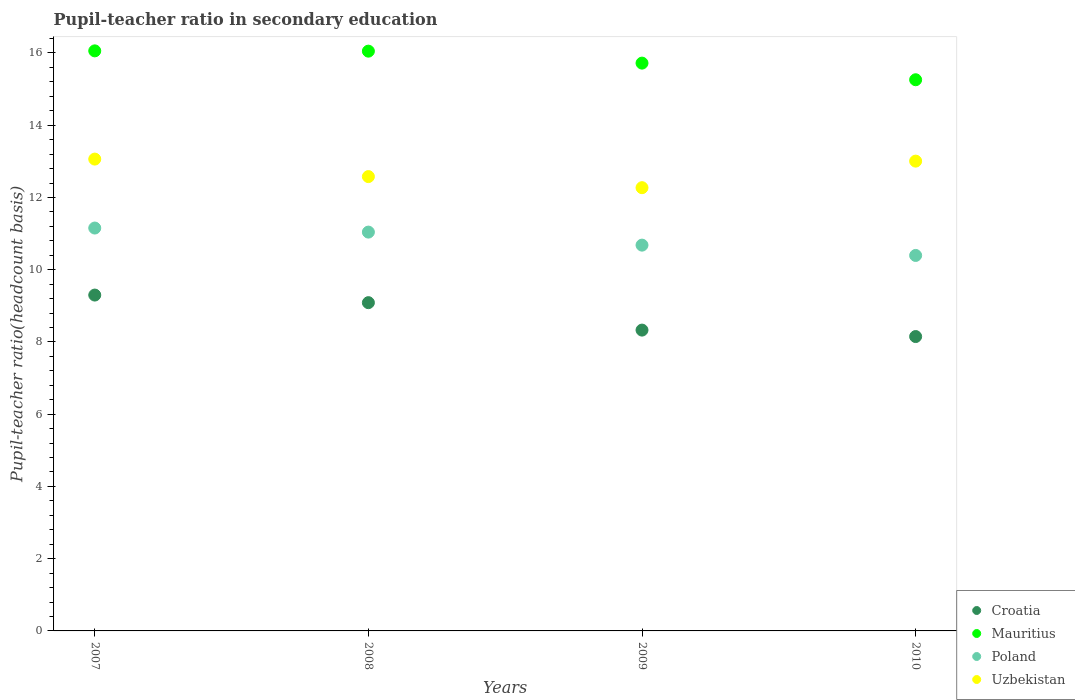How many different coloured dotlines are there?
Offer a very short reply. 4. What is the pupil-teacher ratio in secondary education in Uzbekistan in 2009?
Your answer should be compact. 12.27. Across all years, what is the maximum pupil-teacher ratio in secondary education in Poland?
Your response must be concise. 11.15. Across all years, what is the minimum pupil-teacher ratio in secondary education in Poland?
Provide a short and direct response. 10.39. In which year was the pupil-teacher ratio in secondary education in Mauritius minimum?
Offer a terse response. 2010. What is the total pupil-teacher ratio in secondary education in Poland in the graph?
Provide a succinct answer. 43.27. What is the difference between the pupil-teacher ratio in secondary education in Uzbekistan in 2008 and that in 2010?
Your answer should be very brief. -0.43. What is the difference between the pupil-teacher ratio in secondary education in Mauritius in 2009 and the pupil-teacher ratio in secondary education in Croatia in 2008?
Keep it short and to the point. 6.63. What is the average pupil-teacher ratio in secondary education in Uzbekistan per year?
Offer a terse response. 12.73. In the year 2009, what is the difference between the pupil-teacher ratio in secondary education in Croatia and pupil-teacher ratio in secondary education in Mauritius?
Keep it short and to the point. -7.39. What is the ratio of the pupil-teacher ratio in secondary education in Uzbekistan in 2007 to that in 2010?
Offer a very short reply. 1. Is the difference between the pupil-teacher ratio in secondary education in Croatia in 2007 and 2008 greater than the difference between the pupil-teacher ratio in secondary education in Mauritius in 2007 and 2008?
Ensure brevity in your answer.  Yes. What is the difference between the highest and the second highest pupil-teacher ratio in secondary education in Croatia?
Provide a short and direct response. 0.21. What is the difference between the highest and the lowest pupil-teacher ratio in secondary education in Uzbekistan?
Provide a succinct answer. 0.79. In how many years, is the pupil-teacher ratio in secondary education in Uzbekistan greater than the average pupil-teacher ratio in secondary education in Uzbekistan taken over all years?
Offer a very short reply. 2. Is it the case that in every year, the sum of the pupil-teacher ratio in secondary education in Croatia and pupil-teacher ratio in secondary education in Uzbekistan  is greater than the sum of pupil-teacher ratio in secondary education in Mauritius and pupil-teacher ratio in secondary education in Poland?
Provide a succinct answer. No. Is the pupil-teacher ratio in secondary education in Mauritius strictly less than the pupil-teacher ratio in secondary education in Uzbekistan over the years?
Make the answer very short. No. How many dotlines are there?
Give a very brief answer. 4. How many years are there in the graph?
Make the answer very short. 4. What is the difference between two consecutive major ticks on the Y-axis?
Your response must be concise. 2. Are the values on the major ticks of Y-axis written in scientific E-notation?
Make the answer very short. No. Does the graph contain any zero values?
Your answer should be compact. No. Does the graph contain grids?
Your answer should be very brief. No. How many legend labels are there?
Make the answer very short. 4. What is the title of the graph?
Make the answer very short. Pupil-teacher ratio in secondary education. What is the label or title of the Y-axis?
Make the answer very short. Pupil-teacher ratio(headcount basis). What is the Pupil-teacher ratio(headcount basis) in Croatia in 2007?
Provide a short and direct response. 9.3. What is the Pupil-teacher ratio(headcount basis) of Mauritius in 2007?
Give a very brief answer. 16.06. What is the Pupil-teacher ratio(headcount basis) in Poland in 2007?
Offer a very short reply. 11.15. What is the Pupil-teacher ratio(headcount basis) in Uzbekistan in 2007?
Your answer should be very brief. 13.06. What is the Pupil-teacher ratio(headcount basis) in Croatia in 2008?
Your response must be concise. 9.09. What is the Pupil-teacher ratio(headcount basis) in Mauritius in 2008?
Provide a short and direct response. 16.05. What is the Pupil-teacher ratio(headcount basis) of Poland in 2008?
Your answer should be very brief. 11.04. What is the Pupil-teacher ratio(headcount basis) of Uzbekistan in 2008?
Ensure brevity in your answer.  12.58. What is the Pupil-teacher ratio(headcount basis) of Croatia in 2009?
Your answer should be very brief. 8.33. What is the Pupil-teacher ratio(headcount basis) in Mauritius in 2009?
Offer a terse response. 15.72. What is the Pupil-teacher ratio(headcount basis) in Poland in 2009?
Offer a terse response. 10.68. What is the Pupil-teacher ratio(headcount basis) of Uzbekistan in 2009?
Your answer should be very brief. 12.27. What is the Pupil-teacher ratio(headcount basis) of Croatia in 2010?
Offer a very short reply. 8.15. What is the Pupil-teacher ratio(headcount basis) in Mauritius in 2010?
Provide a short and direct response. 15.26. What is the Pupil-teacher ratio(headcount basis) of Poland in 2010?
Provide a succinct answer. 10.39. What is the Pupil-teacher ratio(headcount basis) of Uzbekistan in 2010?
Offer a very short reply. 13.01. Across all years, what is the maximum Pupil-teacher ratio(headcount basis) in Croatia?
Give a very brief answer. 9.3. Across all years, what is the maximum Pupil-teacher ratio(headcount basis) of Mauritius?
Your answer should be compact. 16.06. Across all years, what is the maximum Pupil-teacher ratio(headcount basis) of Poland?
Give a very brief answer. 11.15. Across all years, what is the maximum Pupil-teacher ratio(headcount basis) in Uzbekistan?
Ensure brevity in your answer.  13.06. Across all years, what is the minimum Pupil-teacher ratio(headcount basis) in Croatia?
Your answer should be very brief. 8.15. Across all years, what is the minimum Pupil-teacher ratio(headcount basis) of Mauritius?
Give a very brief answer. 15.26. Across all years, what is the minimum Pupil-teacher ratio(headcount basis) in Poland?
Provide a succinct answer. 10.39. Across all years, what is the minimum Pupil-teacher ratio(headcount basis) in Uzbekistan?
Provide a succinct answer. 12.27. What is the total Pupil-teacher ratio(headcount basis) of Croatia in the graph?
Your response must be concise. 34.86. What is the total Pupil-teacher ratio(headcount basis) of Mauritius in the graph?
Offer a terse response. 63.09. What is the total Pupil-teacher ratio(headcount basis) in Poland in the graph?
Give a very brief answer. 43.27. What is the total Pupil-teacher ratio(headcount basis) in Uzbekistan in the graph?
Your answer should be compact. 50.92. What is the difference between the Pupil-teacher ratio(headcount basis) in Croatia in 2007 and that in 2008?
Make the answer very short. 0.21. What is the difference between the Pupil-teacher ratio(headcount basis) in Mauritius in 2007 and that in 2008?
Your response must be concise. 0.01. What is the difference between the Pupil-teacher ratio(headcount basis) in Poland in 2007 and that in 2008?
Provide a short and direct response. 0.11. What is the difference between the Pupil-teacher ratio(headcount basis) of Uzbekistan in 2007 and that in 2008?
Provide a short and direct response. 0.48. What is the difference between the Pupil-teacher ratio(headcount basis) of Croatia in 2007 and that in 2009?
Provide a succinct answer. 0.97. What is the difference between the Pupil-teacher ratio(headcount basis) of Mauritius in 2007 and that in 2009?
Give a very brief answer. 0.34. What is the difference between the Pupil-teacher ratio(headcount basis) in Poland in 2007 and that in 2009?
Provide a succinct answer. 0.47. What is the difference between the Pupil-teacher ratio(headcount basis) in Uzbekistan in 2007 and that in 2009?
Give a very brief answer. 0.79. What is the difference between the Pupil-teacher ratio(headcount basis) in Croatia in 2007 and that in 2010?
Ensure brevity in your answer.  1.15. What is the difference between the Pupil-teacher ratio(headcount basis) in Mauritius in 2007 and that in 2010?
Keep it short and to the point. 0.8. What is the difference between the Pupil-teacher ratio(headcount basis) of Poland in 2007 and that in 2010?
Provide a succinct answer. 0.76. What is the difference between the Pupil-teacher ratio(headcount basis) of Uzbekistan in 2007 and that in 2010?
Your response must be concise. 0.06. What is the difference between the Pupil-teacher ratio(headcount basis) of Croatia in 2008 and that in 2009?
Provide a succinct answer. 0.76. What is the difference between the Pupil-teacher ratio(headcount basis) in Mauritius in 2008 and that in 2009?
Offer a very short reply. 0.33. What is the difference between the Pupil-teacher ratio(headcount basis) of Poland in 2008 and that in 2009?
Provide a succinct answer. 0.36. What is the difference between the Pupil-teacher ratio(headcount basis) of Uzbekistan in 2008 and that in 2009?
Ensure brevity in your answer.  0.31. What is the difference between the Pupil-teacher ratio(headcount basis) of Croatia in 2008 and that in 2010?
Your response must be concise. 0.94. What is the difference between the Pupil-teacher ratio(headcount basis) in Mauritius in 2008 and that in 2010?
Your answer should be very brief. 0.79. What is the difference between the Pupil-teacher ratio(headcount basis) in Poland in 2008 and that in 2010?
Provide a short and direct response. 0.65. What is the difference between the Pupil-teacher ratio(headcount basis) in Uzbekistan in 2008 and that in 2010?
Offer a terse response. -0.43. What is the difference between the Pupil-teacher ratio(headcount basis) of Croatia in 2009 and that in 2010?
Your answer should be compact. 0.18. What is the difference between the Pupil-teacher ratio(headcount basis) of Mauritius in 2009 and that in 2010?
Provide a short and direct response. 0.46. What is the difference between the Pupil-teacher ratio(headcount basis) of Poland in 2009 and that in 2010?
Make the answer very short. 0.29. What is the difference between the Pupil-teacher ratio(headcount basis) of Uzbekistan in 2009 and that in 2010?
Provide a short and direct response. -0.74. What is the difference between the Pupil-teacher ratio(headcount basis) in Croatia in 2007 and the Pupil-teacher ratio(headcount basis) in Mauritius in 2008?
Your answer should be compact. -6.75. What is the difference between the Pupil-teacher ratio(headcount basis) of Croatia in 2007 and the Pupil-teacher ratio(headcount basis) of Poland in 2008?
Offer a terse response. -1.74. What is the difference between the Pupil-teacher ratio(headcount basis) in Croatia in 2007 and the Pupil-teacher ratio(headcount basis) in Uzbekistan in 2008?
Provide a succinct answer. -3.28. What is the difference between the Pupil-teacher ratio(headcount basis) in Mauritius in 2007 and the Pupil-teacher ratio(headcount basis) in Poland in 2008?
Your answer should be compact. 5.02. What is the difference between the Pupil-teacher ratio(headcount basis) of Mauritius in 2007 and the Pupil-teacher ratio(headcount basis) of Uzbekistan in 2008?
Ensure brevity in your answer.  3.48. What is the difference between the Pupil-teacher ratio(headcount basis) in Poland in 2007 and the Pupil-teacher ratio(headcount basis) in Uzbekistan in 2008?
Your answer should be very brief. -1.42. What is the difference between the Pupil-teacher ratio(headcount basis) in Croatia in 2007 and the Pupil-teacher ratio(headcount basis) in Mauritius in 2009?
Your response must be concise. -6.42. What is the difference between the Pupil-teacher ratio(headcount basis) in Croatia in 2007 and the Pupil-teacher ratio(headcount basis) in Poland in 2009?
Your answer should be compact. -1.38. What is the difference between the Pupil-teacher ratio(headcount basis) in Croatia in 2007 and the Pupil-teacher ratio(headcount basis) in Uzbekistan in 2009?
Your response must be concise. -2.97. What is the difference between the Pupil-teacher ratio(headcount basis) of Mauritius in 2007 and the Pupil-teacher ratio(headcount basis) of Poland in 2009?
Make the answer very short. 5.38. What is the difference between the Pupil-teacher ratio(headcount basis) in Mauritius in 2007 and the Pupil-teacher ratio(headcount basis) in Uzbekistan in 2009?
Your answer should be compact. 3.79. What is the difference between the Pupil-teacher ratio(headcount basis) in Poland in 2007 and the Pupil-teacher ratio(headcount basis) in Uzbekistan in 2009?
Give a very brief answer. -1.12. What is the difference between the Pupil-teacher ratio(headcount basis) of Croatia in 2007 and the Pupil-teacher ratio(headcount basis) of Mauritius in 2010?
Ensure brevity in your answer.  -5.96. What is the difference between the Pupil-teacher ratio(headcount basis) of Croatia in 2007 and the Pupil-teacher ratio(headcount basis) of Poland in 2010?
Ensure brevity in your answer.  -1.1. What is the difference between the Pupil-teacher ratio(headcount basis) of Croatia in 2007 and the Pupil-teacher ratio(headcount basis) of Uzbekistan in 2010?
Give a very brief answer. -3.71. What is the difference between the Pupil-teacher ratio(headcount basis) in Mauritius in 2007 and the Pupil-teacher ratio(headcount basis) in Poland in 2010?
Your answer should be very brief. 5.66. What is the difference between the Pupil-teacher ratio(headcount basis) of Mauritius in 2007 and the Pupil-teacher ratio(headcount basis) of Uzbekistan in 2010?
Keep it short and to the point. 3.05. What is the difference between the Pupil-teacher ratio(headcount basis) of Poland in 2007 and the Pupil-teacher ratio(headcount basis) of Uzbekistan in 2010?
Your answer should be compact. -1.85. What is the difference between the Pupil-teacher ratio(headcount basis) of Croatia in 2008 and the Pupil-teacher ratio(headcount basis) of Mauritius in 2009?
Make the answer very short. -6.63. What is the difference between the Pupil-teacher ratio(headcount basis) of Croatia in 2008 and the Pupil-teacher ratio(headcount basis) of Poland in 2009?
Provide a succinct answer. -1.59. What is the difference between the Pupil-teacher ratio(headcount basis) of Croatia in 2008 and the Pupil-teacher ratio(headcount basis) of Uzbekistan in 2009?
Your response must be concise. -3.18. What is the difference between the Pupil-teacher ratio(headcount basis) in Mauritius in 2008 and the Pupil-teacher ratio(headcount basis) in Poland in 2009?
Offer a terse response. 5.37. What is the difference between the Pupil-teacher ratio(headcount basis) in Mauritius in 2008 and the Pupil-teacher ratio(headcount basis) in Uzbekistan in 2009?
Ensure brevity in your answer.  3.78. What is the difference between the Pupil-teacher ratio(headcount basis) of Poland in 2008 and the Pupil-teacher ratio(headcount basis) of Uzbekistan in 2009?
Ensure brevity in your answer.  -1.23. What is the difference between the Pupil-teacher ratio(headcount basis) in Croatia in 2008 and the Pupil-teacher ratio(headcount basis) in Mauritius in 2010?
Provide a short and direct response. -6.17. What is the difference between the Pupil-teacher ratio(headcount basis) in Croatia in 2008 and the Pupil-teacher ratio(headcount basis) in Poland in 2010?
Give a very brief answer. -1.31. What is the difference between the Pupil-teacher ratio(headcount basis) in Croatia in 2008 and the Pupil-teacher ratio(headcount basis) in Uzbekistan in 2010?
Provide a short and direct response. -3.92. What is the difference between the Pupil-teacher ratio(headcount basis) in Mauritius in 2008 and the Pupil-teacher ratio(headcount basis) in Poland in 2010?
Keep it short and to the point. 5.66. What is the difference between the Pupil-teacher ratio(headcount basis) in Mauritius in 2008 and the Pupil-teacher ratio(headcount basis) in Uzbekistan in 2010?
Ensure brevity in your answer.  3.04. What is the difference between the Pupil-teacher ratio(headcount basis) in Poland in 2008 and the Pupil-teacher ratio(headcount basis) in Uzbekistan in 2010?
Provide a short and direct response. -1.97. What is the difference between the Pupil-teacher ratio(headcount basis) of Croatia in 2009 and the Pupil-teacher ratio(headcount basis) of Mauritius in 2010?
Ensure brevity in your answer.  -6.93. What is the difference between the Pupil-teacher ratio(headcount basis) of Croatia in 2009 and the Pupil-teacher ratio(headcount basis) of Poland in 2010?
Your answer should be very brief. -2.07. What is the difference between the Pupil-teacher ratio(headcount basis) in Croatia in 2009 and the Pupil-teacher ratio(headcount basis) in Uzbekistan in 2010?
Provide a short and direct response. -4.68. What is the difference between the Pupil-teacher ratio(headcount basis) of Mauritius in 2009 and the Pupil-teacher ratio(headcount basis) of Poland in 2010?
Ensure brevity in your answer.  5.32. What is the difference between the Pupil-teacher ratio(headcount basis) of Mauritius in 2009 and the Pupil-teacher ratio(headcount basis) of Uzbekistan in 2010?
Keep it short and to the point. 2.71. What is the difference between the Pupil-teacher ratio(headcount basis) of Poland in 2009 and the Pupil-teacher ratio(headcount basis) of Uzbekistan in 2010?
Provide a short and direct response. -2.33. What is the average Pupil-teacher ratio(headcount basis) in Croatia per year?
Your answer should be very brief. 8.72. What is the average Pupil-teacher ratio(headcount basis) in Mauritius per year?
Offer a very short reply. 15.77. What is the average Pupil-teacher ratio(headcount basis) of Poland per year?
Your answer should be compact. 10.82. What is the average Pupil-teacher ratio(headcount basis) in Uzbekistan per year?
Provide a short and direct response. 12.73. In the year 2007, what is the difference between the Pupil-teacher ratio(headcount basis) in Croatia and Pupil-teacher ratio(headcount basis) in Mauritius?
Make the answer very short. -6.76. In the year 2007, what is the difference between the Pupil-teacher ratio(headcount basis) in Croatia and Pupil-teacher ratio(headcount basis) in Poland?
Your response must be concise. -1.86. In the year 2007, what is the difference between the Pupil-teacher ratio(headcount basis) in Croatia and Pupil-teacher ratio(headcount basis) in Uzbekistan?
Provide a succinct answer. -3.76. In the year 2007, what is the difference between the Pupil-teacher ratio(headcount basis) in Mauritius and Pupil-teacher ratio(headcount basis) in Poland?
Your answer should be very brief. 4.91. In the year 2007, what is the difference between the Pupil-teacher ratio(headcount basis) of Mauritius and Pupil-teacher ratio(headcount basis) of Uzbekistan?
Ensure brevity in your answer.  3. In the year 2007, what is the difference between the Pupil-teacher ratio(headcount basis) of Poland and Pupil-teacher ratio(headcount basis) of Uzbekistan?
Provide a short and direct response. -1.91. In the year 2008, what is the difference between the Pupil-teacher ratio(headcount basis) in Croatia and Pupil-teacher ratio(headcount basis) in Mauritius?
Offer a very short reply. -6.96. In the year 2008, what is the difference between the Pupil-teacher ratio(headcount basis) of Croatia and Pupil-teacher ratio(headcount basis) of Poland?
Ensure brevity in your answer.  -1.95. In the year 2008, what is the difference between the Pupil-teacher ratio(headcount basis) in Croatia and Pupil-teacher ratio(headcount basis) in Uzbekistan?
Make the answer very short. -3.49. In the year 2008, what is the difference between the Pupil-teacher ratio(headcount basis) of Mauritius and Pupil-teacher ratio(headcount basis) of Poland?
Offer a terse response. 5.01. In the year 2008, what is the difference between the Pupil-teacher ratio(headcount basis) of Mauritius and Pupil-teacher ratio(headcount basis) of Uzbekistan?
Provide a short and direct response. 3.47. In the year 2008, what is the difference between the Pupil-teacher ratio(headcount basis) of Poland and Pupil-teacher ratio(headcount basis) of Uzbekistan?
Provide a short and direct response. -1.54. In the year 2009, what is the difference between the Pupil-teacher ratio(headcount basis) of Croatia and Pupil-teacher ratio(headcount basis) of Mauritius?
Offer a very short reply. -7.39. In the year 2009, what is the difference between the Pupil-teacher ratio(headcount basis) of Croatia and Pupil-teacher ratio(headcount basis) of Poland?
Keep it short and to the point. -2.35. In the year 2009, what is the difference between the Pupil-teacher ratio(headcount basis) of Croatia and Pupil-teacher ratio(headcount basis) of Uzbekistan?
Offer a terse response. -3.94. In the year 2009, what is the difference between the Pupil-teacher ratio(headcount basis) of Mauritius and Pupil-teacher ratio(headcount basis) of Poland?
Provide a short and direct response. 5.04. In the year 2009, what is the difference between the Pupil-teacher ratio(headcount basis) of Mauritius and Pupil-teacher ratio(headcount basis) of Uzbekistan?
Make the answer very short. 3.45. In the year 2009, what is the difference between the Pupil-teacher ratio(headcount basis) of Poland and Pupil-teacher ratio(headcount basis) of Uzbekistan?
Keep it short and to the point. -1.59. In the year 2010, what is the difference between the Pupil-teacher ratio(headcount basis) of Croatia and Pupil-teacher ratio(headcount basis) of Mauritius?
Give a very brief answer. -7.11. In the year 2010, what is the difference between the Pupil-teacher ratio(headcount basis) of Croatia and Pupil-teacher ratio(headcount basis) of Poland?
Provide a short and direct response. -2.25. In the year 2010, what is the difference between the Pupil-teacher ratio(headcount basis) in Croatia and Pupil-teacher ratio(headcount basis) in Uzbekistan?
Your response must be concise. -4.86. In the year 2010, what is the difference between the Pupil-teacher ratio(headcount basis) of Mauritius and Pupil-teacher ratio(headcount basis) of Poland?
Provide a short and direct response. 4.86. In the year 2010, what is the difference between the Pupil-teacher ratio(headcount basis) in Mauritius and Pupil-teacher ratio(headcount basis) in Uzbekistan?
Provide a succinct answer. 2.25. In the year 2010, what is the difference between the Pupil-teacher ratio(headcount basis) of Poland and Pupil-teacher ratio(headcount basis) of Uzbekistan?
Keep it short and to the point. -2.61. What is the ratio of the Pupil-teacher ratio(headcount basis) in Croatia in 2007 to that in 2008?
Give a very brief answer. 1.02. What is the ratio of the Pupil-teacher ratio(headcount basis) of Mauritius in 2007 to that in 2008?
Your response must be concise. 1. What is the ratio of the Pupil-teacher ratio(headcount basis) in Poland in 2007 to that in 2008?
Offer a terse response. 1.01. What is the ratio of the Pupil-teacher ratio(headcount basis) in Uzbekistan in 2007 to that in 2008?
Your response must be concise. 1.04. What is the ratio of the Pupil-teacher ratio(headcount basis) of Croatia in 2007 to that in 2009?
Give a very brief answer. 1.12. What is the ratio of the Pupil-teacher ratio(headcount basis) of Mauritius in 2007 to that in 2009?
Offer a terse response. 1.02. What is the ratio of the Pupil-teacher ratio(headcount basis) in Poland in 2007 to that in 2009?
Offer a terse response. 1.04. What is the ratio of the Pupil-teacher ratio(headcount basis) in Uzbekistan in 2007 to that in 2009?
Your response must be concise. 1.06. What is the ratio of the Pupil-teacher ratio(headcount basis) in Croatia in 2007 to that in 2010?
Keep it short and to the point. 1.14. What is the ratio of the Pupil-teacher ratio(headcount basis) of Mauritius in 2007 to that in 2010?
Provide a short and direct response. 1.05. What is the ratio of the Pupil-teacher ratio(headcount basis) of Poland in 2007 to that in 2010?
Your answer should be compact. 1.07. What is the ratio of the Pupil-teacher ratio(headcount basis) in Uzbekistan in 2007 to that in 2010?
Offer a very short reply. 1. What is the ratio of the Pupil-teacher ratio(headcount basis) of Croatia in 2008 to that in 2009?
Offer a terse response. 1.09. What is the ratio of the Pupil-teacher ratio(headcount basis) of Mauritius in 2008 to that in 2009?
Offer a very short reply. 1.02. What is the ratio of the Pupil-teacher ratio(headcount basis) of Poland in 2008 to that in 2009?
Your answer should be very brief. 1.03. What is the ratio of the Pupil-teacher ratio(headcount basis) of Croatia in 2008 to that in 2010?
Give a very brief answer. 1.12. What is the ratio of the Pupil-teacher ratio(headcount basis) in Mauritius in 2008 to that in 2010?
Offer a very short reply. 1.05. What is the ratio of the Pupil-teacher ratio(headcount basis) of Poland in 2008 to that in 2010?
Offer a very short reply. 1.06. What is the ratio of the Pupil-teacher ratio(headcount basis) of Uzbekistan in 2008 to that in 2010?
Ensure brevity in your answer.  0.97. What is the ratio of the Pupil-teacher ratio(headcount basis) of Croatia in 2009 to that in 2010?
Keep it short and to the point. 1.02. What is the ratio of the Pupil-teacher ratio(headcount basis) of Mauritius in 2009 to that in 2010?
Make the answer very short. 1.03. What is the ratio of the Pupil-teacher ratio(headcount basis) of Poland in 2009 to that in 2010?
Your answer should be compact. 1.03. What is the ratio of the Pupil-teacher ratio(headcount basis) in Uzbekistan in 2009 to that in 2010?
Provide a succinct answer. 0.94. What is the difference between the highest and the second highest Pupil-teacher ratio(headcount basis) of Croatia?
Your response must be concise. 0.21. What is the difference between the highest and the second highest Pupil-teacher ratio(headcount basis) in Mauritius?
Your answer should be very brief. 0.01. What is the difference between the highest and the second highest Pupil-teacher ratio(headcount basis) in Poland?
Make the answer very short. 0.11. What is the difference between the highest and the second highest Pupil-teacher ratio(headcount basis) of Uzbekistan?
Keep it short and to the point. 0.06. What is the difference between the highest and the lowest Pupil-teacher ratio(headcount basis) of Croatia?
Your answer should be compact. 1.15. What is the difference between the highest and the lowest Pupil-teacher ratio(headcount basis) in Mauritius?
Keep it short and to the point. 0.8. What is the difference between the highest and the lowest Pupil-teacher ratio(headcount basis) in Poland?
Make the answer very short. 0.76. What is the difference between the highest and the lowest Pupil-teacher ratio(headcount basis) in Uzbekistan?
Offer a terse response. 0.79. 